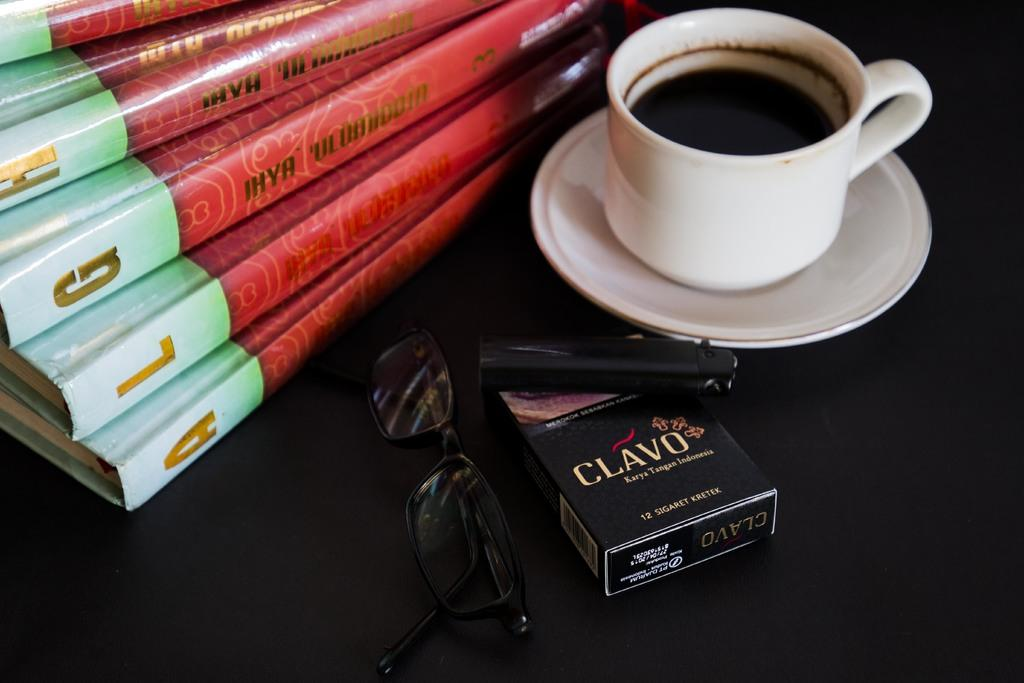What type of furniture is present in the image? There is a table in the image. What items can be seen on the table? There are glasses, a lighter, a cigarette pack, a cup, a saucer, and books on the table. Can you describe the purpose of the lighter? The lighter is likely used for lighting cigarettes, as it is on the table with a cigarette pack. What might be used for holding or serving a beverage? The cup and saucer on the table might be used for holding or serving a beverage. What type of foot is visible on the table in the image? There are no feet visible on the table in the image. Can you describe the pocket on the table in the image? There is no pocket present on the table in the image. 